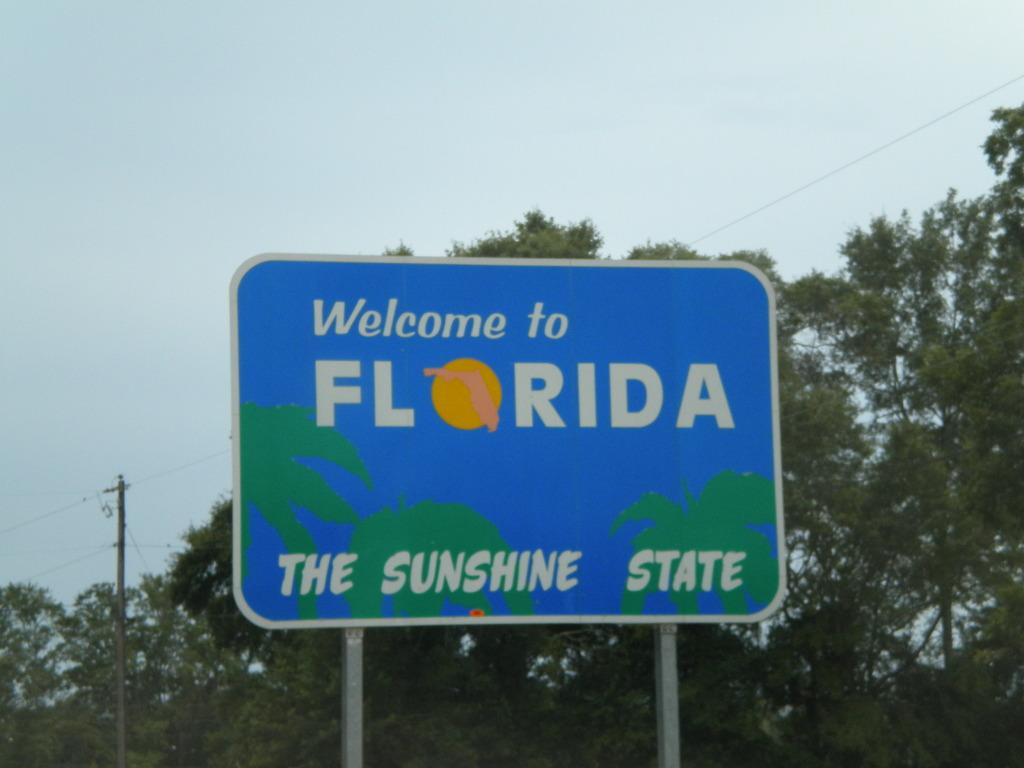Provide a one-sentence caption for the provided image. a Welcome to Florida The Sunshine State sign along a road. 